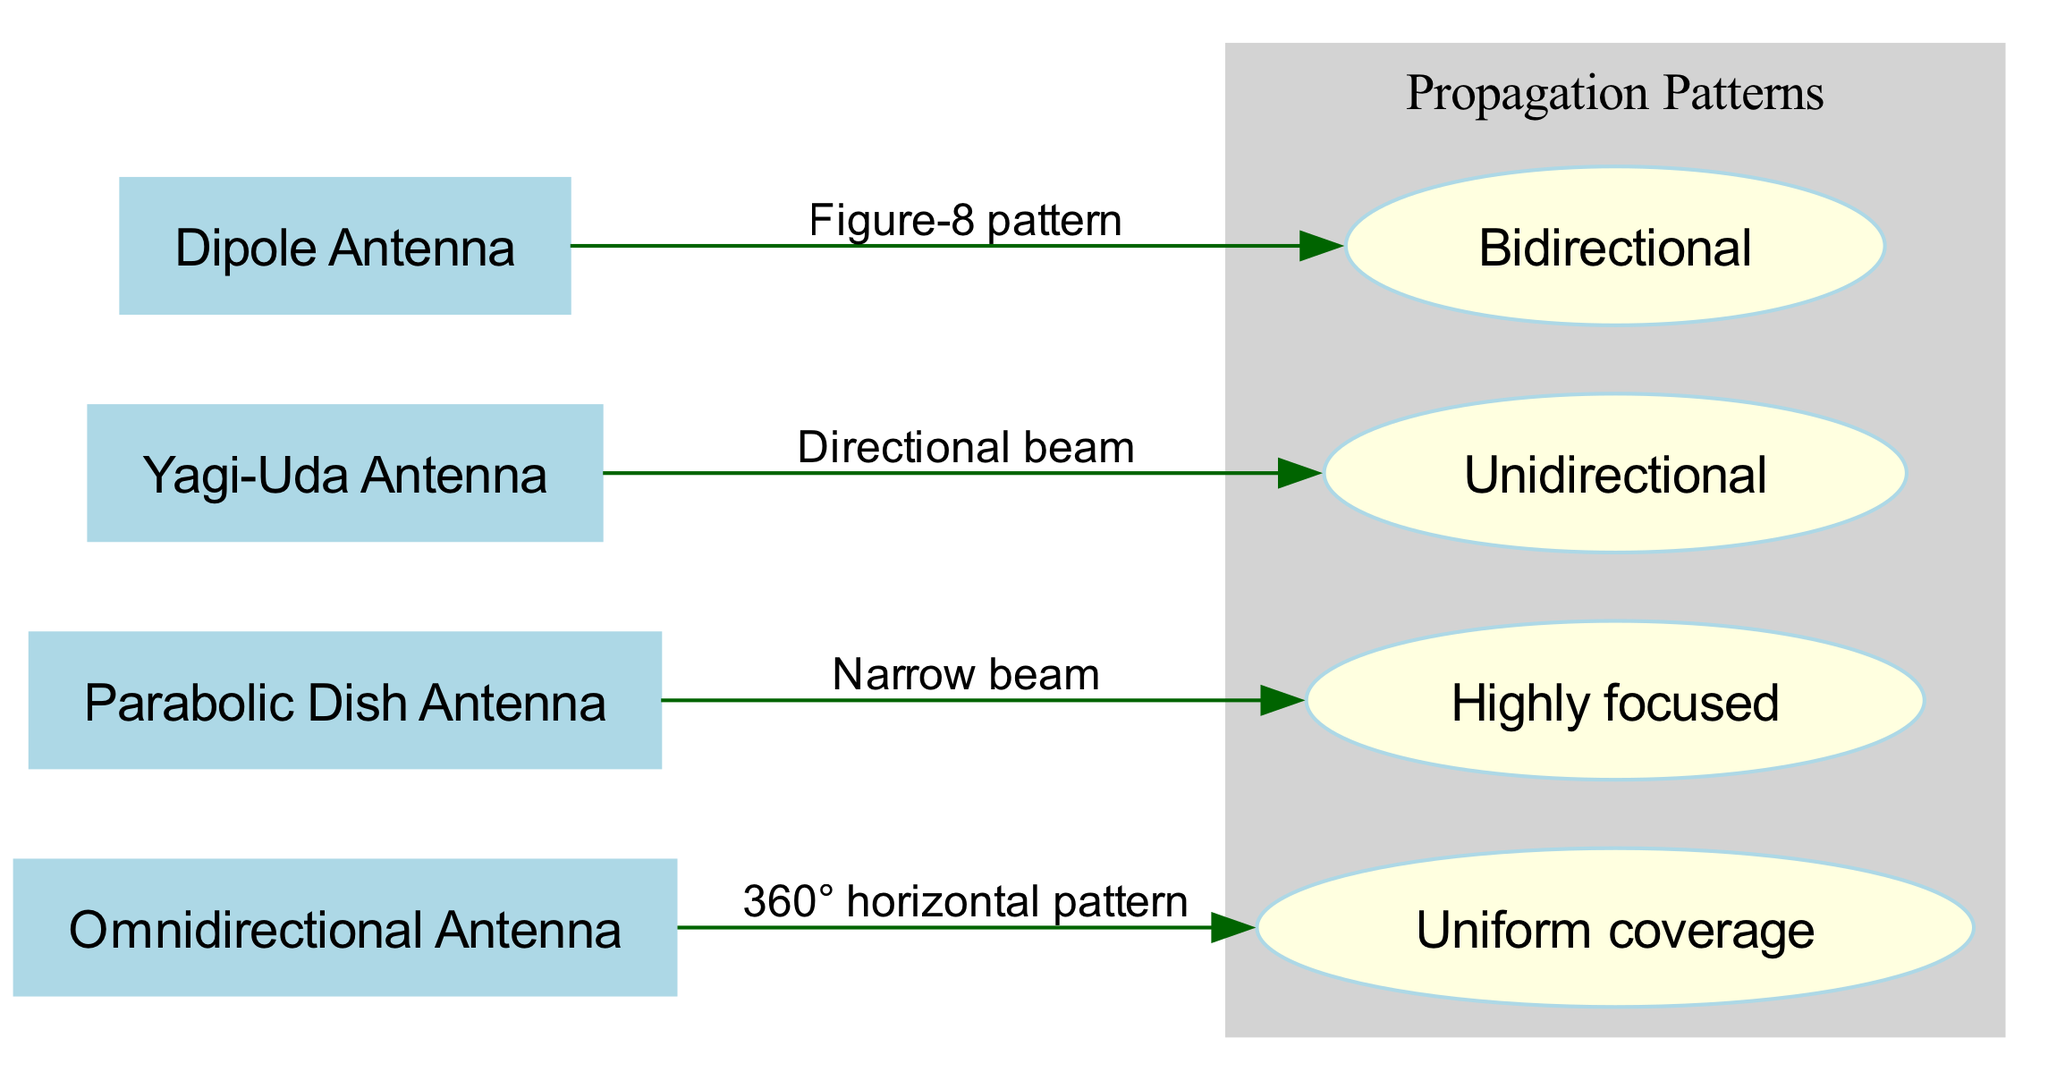What is the signal propagation pattern for a Dipole Antenna? The Dipole Antenna is connected to the "pattern1" node, which indicates that its signal propagation pattern is a Figure-8 pattern. This information is represented in the edge label that connects them.
Answer: Figure-8 pattern How many types of antennas are present in the diagram? The diagram lists four nodes under 'nodes': Dipole Antenna, Yagi-Uda Antenna, Parabolic Dish Antenna, and Omnidirectional Antenna. Counting them gives a total of four types.
Answer: 4 What does the Yagi-Uda Antenna's signal pattern illustrate? From the Yagi-Uda Antenna node, there is an edge leading to "pattern2," which states that it has a directional beam pattern. Therefore, this antenna's signal pattern illustrates a directional beam.
Answer: Directional beam Which antenna type provides uniform coverage? The Omnidirectional Antenna links to "pattern4," which indicates a 360° horizontal pattern. This corresponds to the description of providing uniform coverage, as it emits signals equally in all directions.
Answer: Omnidirectional Antenna What is the relationship between the Parabolic Dish Antenna and its signal pattern? The Parabolic Dish Antenna is connected to "pattern3," labeled as a narrow beam. This relationship shows that the Parabolic Dish Antenna focuses its signal in a narrow direction, indicated by the edge connecting them.
Answer: Narrow beam Which antenna type is unidirectional? Referring to the edge from the Yagi-Uda Antenna to "pattern2," which signifies a unidirectional signal pattern, we find that the Yagi-Uda Antenna is classified as unidirectional.
Answer: Yagi-Uda Antenna 